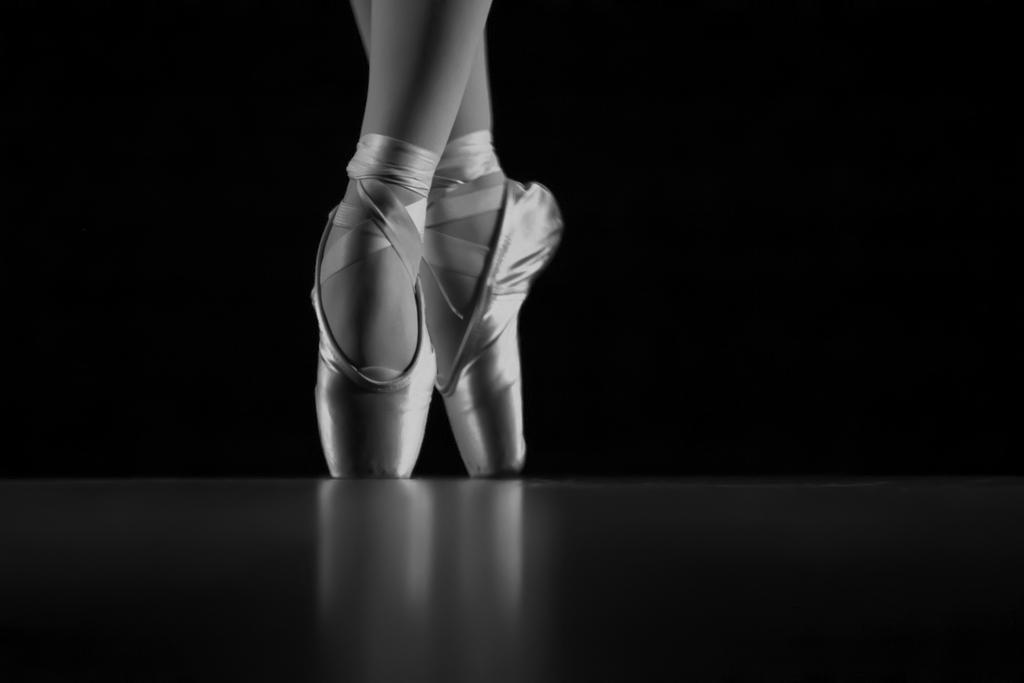How would you summarize this image in a sentence or two? It is a black and white image. In this image we can see the women legs on the floor and the background is in black color. 